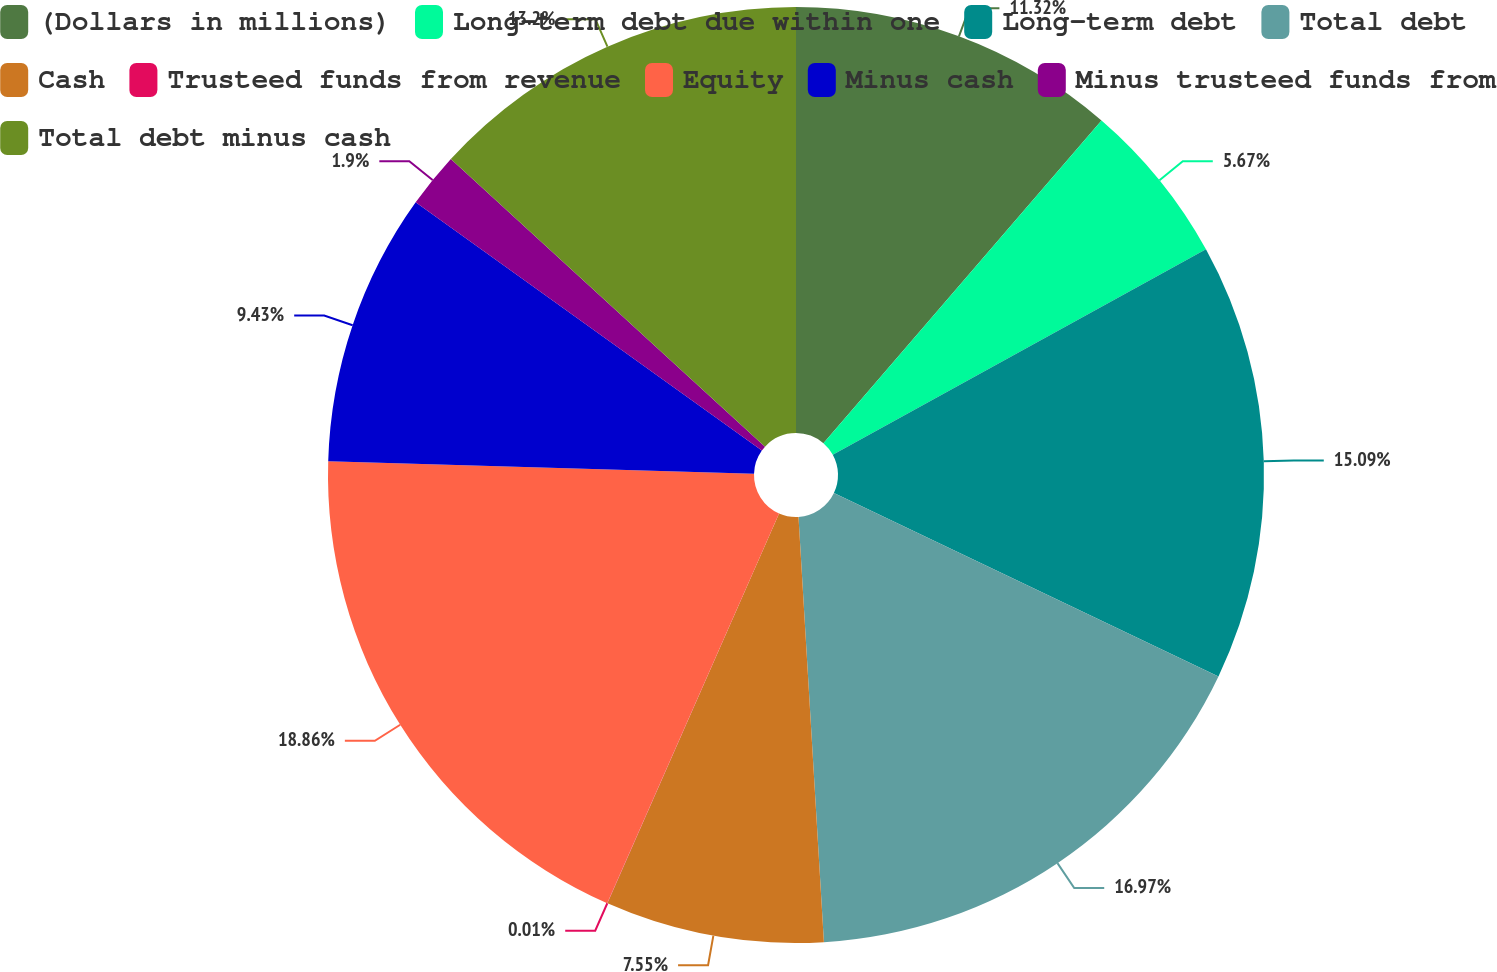Convert chart to OTSL. <chart><loc_0><loc_0><loc_500><loc_500><pie_chart><fcel>(Dollars in millions)<fcel>Long-term debt due within one<fcel>Long-term debt<fcel>Total debt<fcel>Cash<fcel>Trusteed funds from revenue<fcel>Equity<fcel>Minus cash<fcel>Minus trusteed funds from<fcel>Total debt minus cash<nl><fcel>11.32%<fcel>5.67%<fcel>15.09%<fcel>16.97%<fcel>7.55%<fcel>0.01%<fcel>18.86%<fcel>9.43%<fcel>1.9%<fcel>13.2%<nl></chart> 